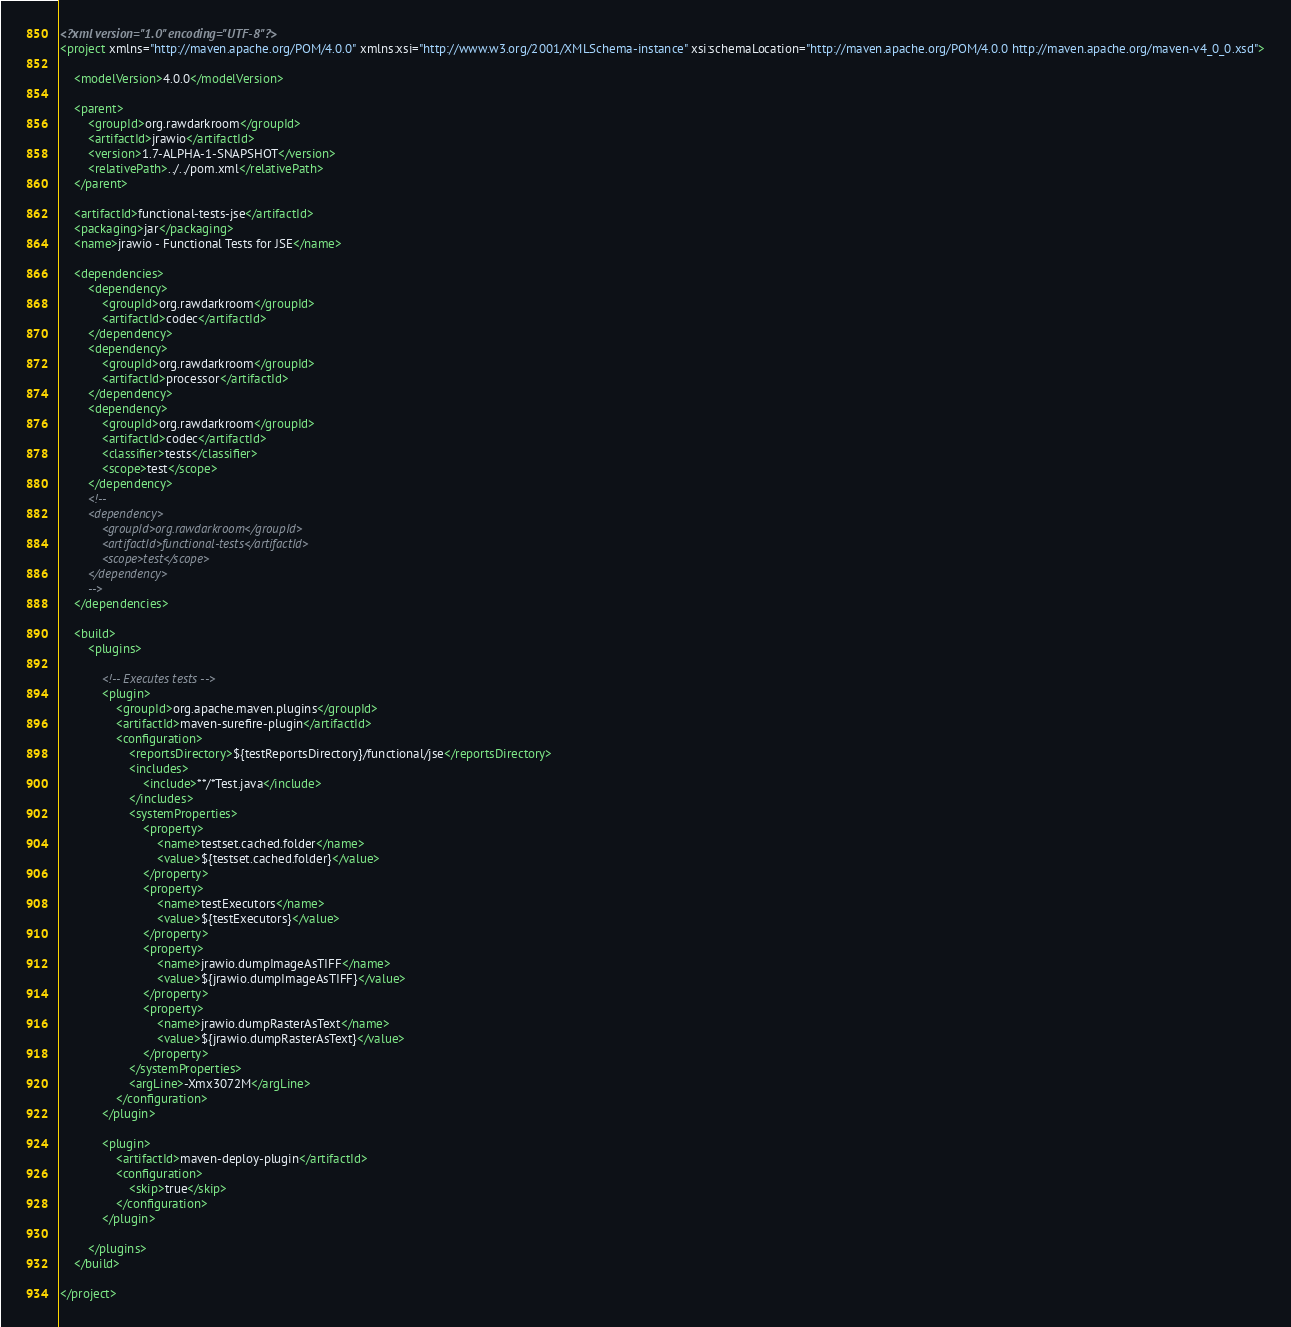Convert code to text. <code><loc_0><loc_0><loc_500><loc_500><_XML_><?xml version="1.0" encoding="UTF-8"?>
<project xmlns="http://maven.apache.org/POM/4.0.0" xmlns:xsi="http://www.w3.org/2001/XMLSchema-instance" xsi:schemaLocation="http://maven.apache.org/POM/4.0.0 http://maven.apache.org/maven-v4_0_0.xsd">

    <modelVersion>4.0.0</modelVersion>

    <parent>
        <groupId>org.rawdarkroom</groupId>
        <artifactId>jrawio</artifactId>
        <version>1.7-ALPHA-1-SNAPSHOT</version>
        <relativePath>../../pom.xml</relativePath>
    </parent>

    <artifactId>functional-tests-jse</artifactId>
    <packaging>jar</packaging>
    <name>jrawio - Functional Tests for JSE</name>

    <dependencies>
        <dependency>
            <groupId>org.rawdarkroom</groupId>
            <artifactId>codec</artifactId>
        </dependency>
        <dependency>
            <groupId>org.rawdarkroom</groupId>
            <artifactId>processor</artifactId>
        </dependency>
        <dependency>
            <groupId>org.rawdarkroom</groupId>
            <artifactId>codec</artifactId>
            <classifier>tests</classifier>
            <scope>test</scope>
        </dependency>
        <!--
        <dependency>
            <groupId>org.rawdarkroom</groupId>
            <artifactId>functional-tests</artifactId>
            <scope>test</scope>
        </dependency>
        -->
    </dependencies>

    <build>
        <plugins>

            <!-- Executes tests -->
            <plugin>
                <groupId>org.apache.maven.plugins</groupId>
                <artifactId>maven-surefire-plugin</artifactId>
                <configuration>
                    <reportsDirectory>${testReportsDirectory}/functional/jse</reportsDirectory>
                    <includes>
                        <include>**/*Test.java</include>
                    </includes>
                    <systemProperties>
                        <property>
                            <name>testset.cached.folder</name>
                            <value>${testset.cached.folder}</value>
                        </property>
                        <property>
                            <name>testExecutors</name>
                            <value>${testExecutors}</value>
                        </property>
                        <property>
                            <name>jrawio.dumpImageAsTIFF</name>
                            <value>${jrawio.dumpImageAsTIFF}</value>
                        </property>
                        <property>
                            <name>jrawio.dumpRasterAsText</name>
                            <value>${jrawio.dumpRasterAsText}</value>
                        </property>
                    </systemProperties>
                    <argLine>-Xmx3072M</argLine>
                </configuration>
            </plugin>

            <plugin>
                <artifactId>maven-deploy-plugin</artifactId>
                <configuration>
                    <skip>true</skip>
                </configuration>
            </plugin>
            
        </plugins>
    </build>

</project>

</code> 